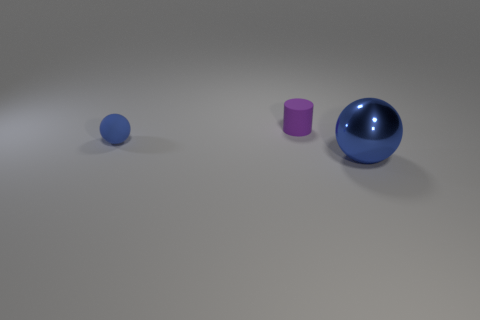Subtract all gray cylinders. Subtract all brown cubes. How many cylinders are left? 1 Add 3 red metal cylinders. How many objects exist? 6 Subtract all cylinders. How many objects are left? 2 Subtract all large metallic blocks. Subtract all small balls. How many objects are left? 2 Add 3 tiny blue things. How many tiny blue things are left? 4 Add 3 large blue cylinders. How many large blue cylinders exist? 3 Subtract 0 yellow cylinders. How many objects are left? 3 